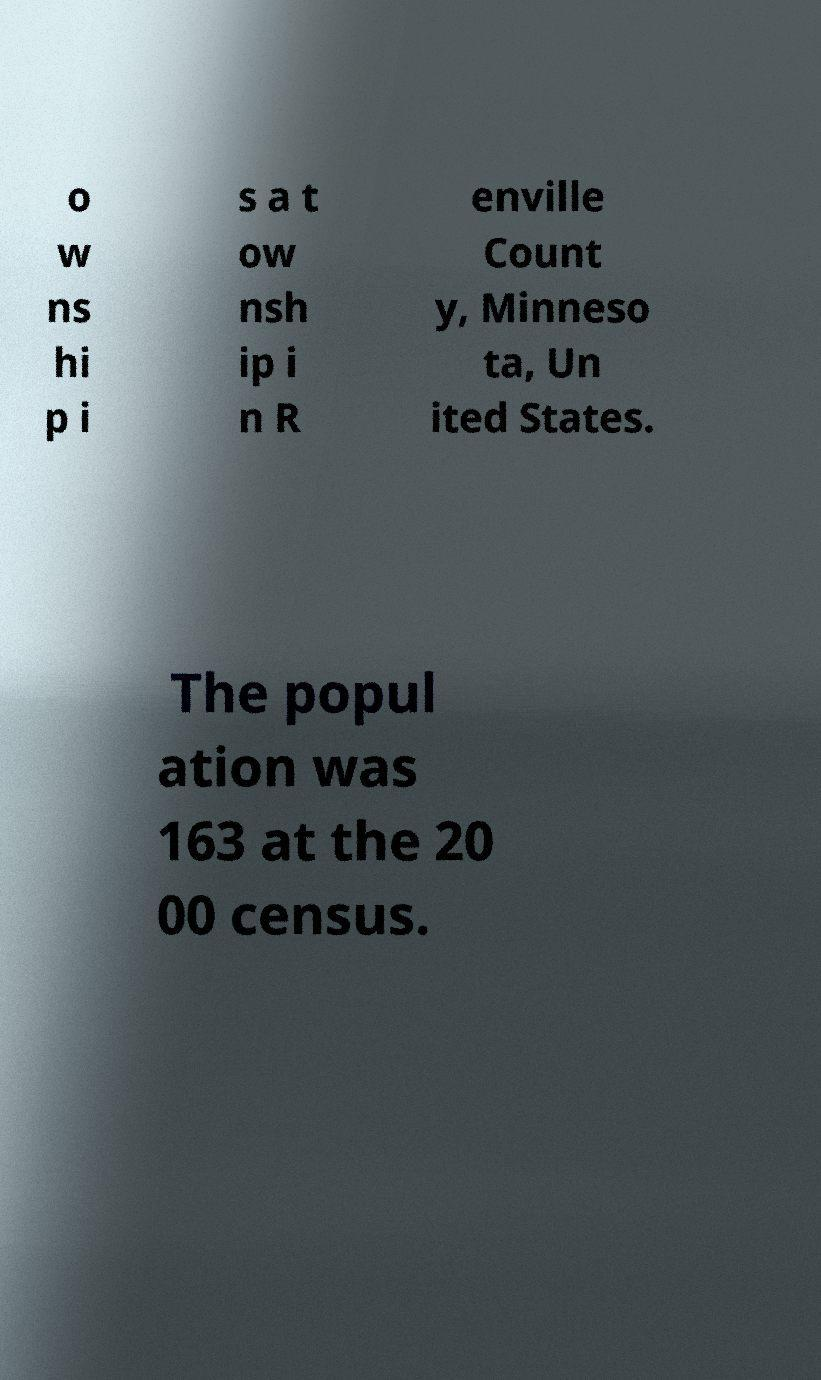Could you assist in decoding the text presented in this image and type it out clearly? o w ns hi p i s a t ow nsh ip i n R enville Count y, Minneso ta, Un ited States. The popul ation was 163 at the 20 00 census. 